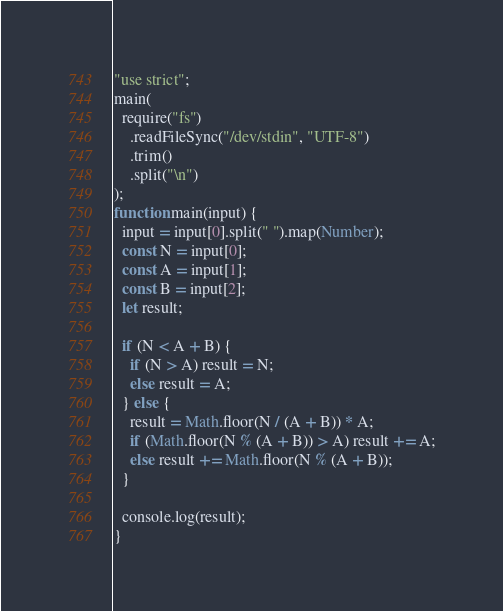<code> <loc_0><loc_0><loc_500><loc_500><_JavaScript_>"use strict";
main(
  require("fs")
    .readFileSync("/dev/stdin", "UTF-8")
    .trim()
    .split("\n")
);
function main(input) {
  input = input[0].split(" ").map(Number);
  const N = input[0];
  const A = input[1];
  const B = input[2];
  let result;

  if (N < A + B) {
    if (N > A) result = N;
    else result = A;
  } else {
    result = Math.floor(N / (A + B)) * A;
    if (Math.floor(N % (A + B)) > A) result += A;
    else result += Math.floor(N % (A + B));
  }

  console.log(result);
}
</code> 